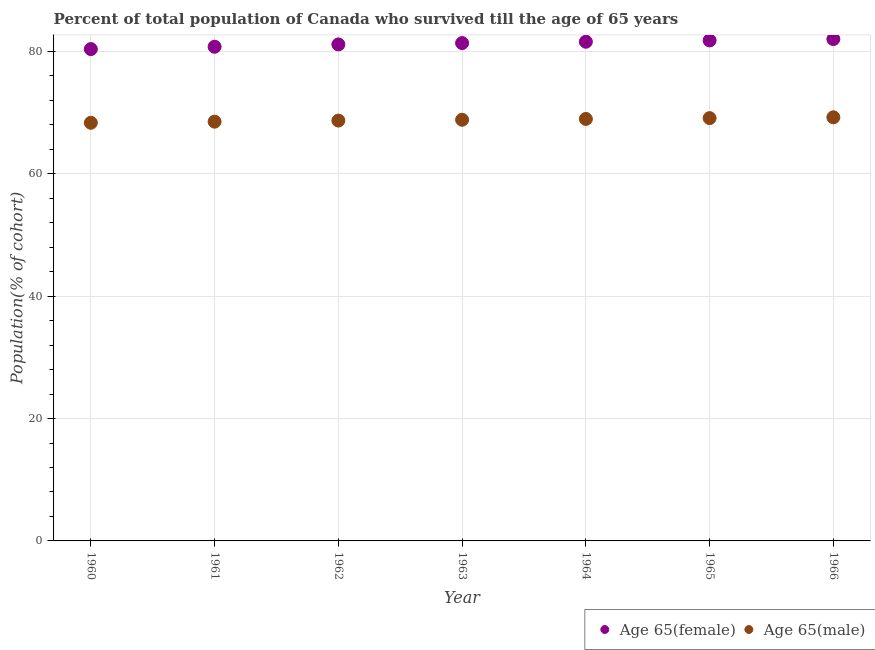What is the percentage of male population who survived till age of 65 in 1964?
Your answer should be compact. 68.96. Across all years, what is the maximum percentage of male population who survived till age of 65?
Ensure brevity in your answer.  69.23. Across all years, what is the minimum percentage of female population who survived till age of 65?
Ensure brevity in your answer.  80.38. In which year was the percentage of female population who survived till age of 65 maximum?
Keep it short and to the point. 1966. What is the total percentage of female population who survived till age of 65 in the graph?
Your answer should be very brief. 569.01. What is the difference between the percentage of female population who survived till age of 65 in 1960 and that in 1965?
Your answer should be very brief. -1.42. What is the difference between the percentage of male population who survived till age of 65 in 1963 and the percentage of female population who survived till age of 65 in 1962?
Make the answer very short. -12.31. What is the average percentage of male population who survived till age of 65 per year?
Provide a succinct answer. 68.81. In the year 1962, what is the difference between the percentage of male population who survived till age of 65 and percentage of female population who survived till age of 65?
Provide a short and direct response. -12.44. In how many years, is the percentage of male population who survived till age of 65 greater than 60 %?
Provide a succinct answer. 7. What is the ratio of the percentage of male population who survived till age of 65 in 1961 to that in 1965?
Offer a very short reply. 0.99. Is the percentage of male population who survived till age of 65 in 1963 less than that in 1964?
Keep it short and to the point. Yes. Is the difference between the percentage of male population who survived till age of 65 in 1961 and 1962 greater than the difference between the percentage of female population who survived till age of 65 in 1961 and 1962?
Provide a succinct answer. Yes. What is the difference between the highest and the second highest percentage of male population who survived till age of 65?
Ensure brevity in your answer.  0.13. What is the difference between the highest and the lowest percentage of female population who survived till age of 65?
Keep it short and to the point. 1.64. Is the sum of the percentage of female population who survived till age of 65 in 1961 and 1963 greater than the maximum percentage of male population who survived till age of 65 across all years?
Keep it short and to the point. Yes. Does the percentage of male population who survived till age of 65 monotonically increase over the years?
Offer a terse response. Yes. How many dotlines are there?
Offer a very short reply. 2. How many years are there in the graph?
Keep it short and to the point. 7. What is the difference between two consecutive major ticks on the Y-axis?
Give a very brief answer. 20. Are the values on the major ticks of Y-axis written in scientific E-notation?
Provide a short and direct response. No. Does the graph contain any zero values?
Ensure brevity in your answer.  No. Where does the legend appear in the graph?
Your response must be concise. Bottom right. How many legend labels are there?
Your answer should be compact. 2. How are the legend labels stacked?
Provide a short and direct response. Horizontal. What is the title of the graph?
Your answer should be compact. Percent of total population of Canada who survived till the age of 65 years. Does "Working only" appear as one of the legend labels in the graph?
Offer a terse response. No. What is the label or title of the Y-axis?
Your answer should be compact. Population(% of cohort). What is the Population(% of cohort) of Age 65(female) in 1960?
Your response must be concise. 80.38. What is the Population(% of cohort) in Age 65(male) in 1960?
Offer a terse response. 68.33. What is the Population(% of cohort) in Age 65(female) in 1961?
Offer a very short reply. 80.76. What is the Population(% of cohort) in Age 65(male) in 1961?
Provide a succinct answer. 68.51. What is the Population(% of cohort) in Age 65(female) in 1962?
Make the answer very short. 81.14. What is the Population(% of cohort) in Age 65(male) in 1962?
Give a very brief answer. 68.69. What is the Population(% of cohort) of Age 65(female) in 1963?
Provide a short and direct response. 81.36. What is the Population(% of cohort) in Age 65(male) in 1963?
Offer a very short reply. 68.83. What is the Population(% of cohort) in Age 65(female) in 1964?
Offer a very short reply. 81.57. What is the Population(% of cohort) in Age 65(male) in 1964?
Give a very brief answer. 68.96. What is the Population(% of cohort) in Age 65(female) in 1965?
Offer a terse response. 81.79. What is the Population(% of cohort) of Age 65(male) in 1965?
Give a very brief answer. 69.09. What is the Population(% of cohort) in Age 65(female) in 1966?
Your response must be concise. 82.01. What is the Population(% of cohort) of Age 65(male) in 1966?
Your answer should be very brief. 69.23. Across all years, what is the maximum Population(% of cohort) in Age 65(female)?
Give a very brief answer. 82.01. Across all years, what is the maximum Population(% of cohort) of Age 65(male)?
Your answer should be compact. 69.23. Across all years, what is the minimum Population(% of cohort) in Age 65(female)?
Your answer should be very brief. 80.38. Across all years, what is the minimum Population(% of cohort) of Age 65(male)?
Your answer should be compact. 68.33. What is the total Population(% of cohort) in Age 65(female) in the graph?
Make the answer very short. 569.01. What is the total Population(% of cohort) in Age 65(male) in the graph?
Ensure brevity in your answer.  481.65. What is the difference between the Population(% of cohort) in Age 65(female) in 1960 and that in 1961?
Make the answer very short. -0.38. What is the difference between the Population(% of cohort) of Age 65(male) in 1960 and that in 1961?
Your response must be concise. -0.18. What is the difference between the Population(% of cohort) in Age 65(female) in 1960 and that in 1962?
Your answer should be compact. -0.76. What is the difference between the Population(% of cohort) in Age 65(male) in 1960 and that in 1962?
Your answer should be very brief. -0.36. What is the difference between the Population(% of cohort) of Age 65(female) in 1960 and that in 1963?
Your answer should be compact. -0.98. What is the difference between the Population(% of cohort) in Age 65(male) in 1960 and that in 1963?
Keep it short and to the point. -0.49. What is the difference between the Population(% of cohort) of Age 65(female) in 1960 and that in 1964?
Your response must be concise. -1.2. What is the difference between the Population(% of cohort) in Age 65(male) in 1960 and that in 1964?
Keep it short and to the point. -0.63. What is the difference between the Population(% of cohort) in Age 65(female) in 1960 and that in 1965?
Ensure brevity in your answer.  -1.42. What is the difference between the Population(% of cohort) in Age 65(male) in 1960 and that in 1965?
Your answer should be compact. -0.76. What is the difference between the Population(% of cohort) in Age 65(female) in 1960 and that in 1966?
Offer a very short reply. -1.64. What is the difference between the Population(% of cohort) of Age 65(male) in 1960 and that in 1966?
Make the answer very short. -0.9. What is the difference between the Population(% of cohort) in Age 65(female) in 1961 and that in 1962?
Make the answer very short. -0.38. What is the difference between the Population(% of cohort) in Age 65(male) in 1961 and that in 1962?
Provide a short and direct response. -0.18. What is the difference between the Population(% of cohort) of Age 65(female) in 1961 and that in 1963?
Your answer should be compact. -0.6. What is the difference between the Population(% of cohort) in Age 65(male) in 1961 and that in 1963?
Provide a succinct answer. -0.31. What is the difference between the Population(% of cohort) in Age 65(female) in 1961 and that in 1964?
Your answer should be compact. -0.82. What is the difference between the Population(% of cohort) in Age 65(male) in 1961 and that in 1964?
Provide a succinct answer. -0.45. What is the difference between the Population(% of cohort) in Age 65(female) in 1961 and that in 1965?
Offer a terse response. -1.04. What is the difference between the Population(% of cohort) of Age 65(male) in 1961 and that in 1965?
Offer a terse response. -0.58. What is the difference between the Population(% of cohort) in Age 65(female) in 1961 and that in 1966?
Keep it short and to the point. -1.26. What is the difference between the Population(% of cohort) in Age 65(male) in 1961 and that in 1966?
Your answer should be very brief. -0.72. What is the difference between the Population(% of cohort) in Age 65(female) in 1962 and that in 1963?
Provide a short and direct response. -0.22. What is the difference between the Population(% of cohort) in Age 65(male) in 1962 and that in 1963?
Your answer should be very brief. -0.13. What is the difference between the Population(% of cohort) in Age 65(female) in 1962 and that in 1964?
Offer a very short reply. -0.44. What is the difference between the Population(% of cohort) in Age 65(male) in 1962 and that in 1964?
Provide a short and direct response. -0.27. What is the difference between the Population(% of cohort) in Age 65(female) in 1962 and that in 1965?
Give a very brief answer. -0.66. What is the difference between the Population(% of cohort) of Age 65(male) in 1962 and that in 1965?
Your response must be concise. -0.4. What is the difference between the Population(% of cohort) in Age 65(female) in 1962 and that in 1966?
Your answer should be compact. -0.88. What is the difference between the Population(% of cohort) in Age 65(male) in 1962 and that in 1966?
Your response must be concise. -0.54. What is the difference between the Population(% of cohort) of Age 65(female) in 1963 and that in 1964?
Your answer should be compact. -0.22. What is the difference between the Population(% of cohort) in Age 65(male) in 1963 and that in 1964?
Give a very brief answer. -0.13. What is the difference between the Population(% of cohort) of Age 65(female) in 1963 and that in 1965?
Offer a terse response. -0.44. What is the difference between the Population(% of cohort) in Age 65(male) in 1963 and that in 1965?
Make the answer very short. -0.27. What is the difference between the Population(% of cohort) of Age 65(female) in 1963 and that in 1966?
Offer a terse response. -0.66. What is the difference between the Population(% of cohort) in Age 65(male) in 1963 and that in 1966?
Your answer should be very brief. -0.4. What is the difference between the Population(% of cohort) in Age 65(female) in 1964 and that in 1965?
Your answer should be very brief. -0.22. What is the difference between the Population(% of cohort) of Age 65(male) in 1964 and that in 1965?
Keep it short and to the point. -0.13. What is the difference between the Population(% of cohort) of Age 65(female) in 1964 and that in 1966?
Provide a short and direct response. -0.44. What is the difference between the Population(% of cohort) of Age 65(male) in 1964 and that in 1966?
Your response must be concise. -0.27. What is the difference between the Population(% of cohort) in Age 65(female) in 1965 and that in 1966?
Offer a terse response. -0.22. What is the difference between the Population(% of cohort) of Age 65(male) in 1965 and that in 1966?
Your response must be concise. -0.13. What is the difference between the Population(% of cohort) in Age 65(female) in 1960 and the Population(% of cohort) in Age 65(male) in 1961?
Make the answer very short. 11.86. What is the difference between the Population(% of cohort) in Age 65(female) in 1960 and the Population(% of cohort) in Age 65(male) in 1962?
Provide a succinct answer. 11.68. What is the difference between the Population(% of cohort) of Age 65(female) in 1960 and the Population(% of cohort) of Age 65(male) in 1963?
Offer a very short reply. 11.55. What is the difference between the Population(% of cohort) of Age 65(female) in 1960 and the Population(% of cohort) of Age 65(male) in 1964?
Your answer should be compact. 11.41. What is the difference between the Population(% of cohort) of Age 65(female) in 1960 and the Population(% of cohort) of Age 65(male) in 1965?
Give a very brief answer. 11.28. What is the difference between the Population(% of cohort) of Age 65(female) in 1960 and the Population(% of cohort) of Age 65(male) in 1966?
Make the answer very short. 11.15. What is the difference between the Population(% of cohort) in Age 65(female) in 1961 and the Population(% of cohort) in Age 65(male) in 1962?
Give a very brief answer. 12.06. What is the difference between the Population(% of cohort) of Age 65(female) in 1961 and the Population(% of cohort) of Age 65(male) in 1963?
Ensure brevity in your answer.  11.93. What is the difference between the Population(% of cohort) of Age 65(female) in 1961 and the Population(% of cohort) of Age 65(male) in 1964?
Give a very brief answer. 11.79. What is the difference between the Population(% of cohort) in Age 65(female) in 1961 and the Population(% of cohort) in Age 65(male) in 1965?
Keep it short and to the point. 11.66. What is the difference between the Population(% of cohort) of Age 65(female) in 1961 and the Population(% of cohort) of Age 65(male) in 1966?
Your response must be concise. 11.53. What is the difference between the Population(% of cohort) in Age 65(female) in 1962 and the Population(% of cohort) in Age 65(male) in 1963?
Provide a short and direct response. 12.31. What is the difference between the Population(% of cohort) of Age 65(female) in 1962 and the Population(% of cohort) of Age 65(male) in 1964?
Your answer should be compact. 12.17. What is the difference between the Population(% of cohort) of Age 65(female) in 1962 and the Population(% of cohort) of Age 65(male) in 1965?
Your response must be concise. 12.04. What is the difference between the Population(% of cohort) in Age 65(female) in 1962 and the Population(% of cohort) in Age 65(male) in 1966?
Provide a succinct answer. 11.91. What is the difference between the Population(% of cohort) of Age 65(female) in 1963 and the Population(% of cohort) of Age 65(male) in 1964?
Provide a short and direct response. 12.39. What is the difference between the Population(% of cohort) in Age 65(female) in 1963 and the Population(% of cohort) in Age 65(male) in 1965?
Provide a short and direct response. 12.26. What is the difference between the Population(% of cohort) in Age 65(female) in 1963 and the Population(% of cohort) in Age 65(male) in 1966?
Offer a terse response. 12.13. What is the difference between the Population(% of cohort) of Age 65(female) in 1964 and the Population(% of cohort) of Age 65(male) in 1965?
Provide a short and direct response. 12.48. What is the difference between the Population(% of cohort) in Age 65(female) in 1964 and the Population(% of cohort) in Age 65(male) in 1966?
Provide a succinct answer. 12.35. What is the difference between the Population(% of cohort) of Age 65(female) in 1965 and the Population(% of cohort) of Age 65(male) in 1966?
Keep it short and to the point. 12.57. What is the average Population(% of cohort) of Age 65(female) per year?
Provide a short and direct response. 81.29. What is the average Population(% of cohort) in Age 65(male) per year?
Your answer should be compact. 68.81. In the year 1960, what is the difference between the Population(% of cohort) in Age 65(female) and Population(% of cohort) in Age 65(male)?
Your answer should be very brief. 12.04. In the year 1961, what is the difference between the Population(% of cohort) of Age 65(female) and Population(% of cohort) of Age 65(male)?
Keep it short and to the point. 12.24. In the year 1962, what is the difference between the Population(% of cohort) in Age 65(female) and Population(% of cohort) in Age 65(male)?
Make the answer very short. 12.44. In the year 1963, what is the difference between the Population(% of cohort) in Age 65(female) and Population(% of cohort) in Age 65(male)?
Your answer should be compact. 12.53. In the year 1964, what is the difference between the Population(% of cohort) in Age 65(female) and Population(% of cohort) in Age 65(male)?
Your response must be concise. 12.61. In the year 1965, what is the difference between the Population(% of cohort) of Age 65(female) and Population(% of cohort) of Age 65(male)?
Offer a very short reply. 12.7. In the year 1966, what is the difference between the Population(% of cohort) in Age 65(female) and Population(% of cohort) in Age 65(male)?
Provide a succinct answer. 12.78. What is the ratio of the Population(% of cohort) of Age 65(female) in 1960 to that in 1961?
Keep it short and to the point. 1. What is the ratio of the Population(% of cohort) in Age 65(female) in 1960 to that in 1962?
Keep it short and to the point. 0.99. What is the ratio of the Population(% of cohort) of Age 65(male) in 1960 to that in 1962?
Your answer should be compact. 0.99. What is the ratio of the Population(% of cohort) of Age 65(female) in 1960 to that in 1963?
Make the answer very short. 0.99. What is the ratio of the Population(% of cohort) of Age 65(male) in 1960 to that in 1963?
Your answer should be compact. 0.99. What is the ratio of the Population(% of cohort) of Age 65(female) in 1960 to that in 1964?
Ensure brevity in your answer.  0.99. What is the ratio of the Population(% of cohort) of Age 65(male) in 1960 to that in 1964?
Your answer should be compact. 0.99. What is the ratio of the Population(% of cohort) in Age 65(female) in 1960 to that in 1965?
Ensure brevity in your answer.  0.98. What is the ratio of the Population(% of cohort) of Age 65(male) in 1960 to that in 1965?
Provide a succinct answer. 0.99. What is the ratio of the Population(% of cohort) in Age 65(female) in 1960 to that in 1966?
Your answer should be compact. 0.98. What is the ratio of the Population(% of cohort) of Age 65(male) in 1960 to that in 1966?
Provide a succinct answer. 0.99. What is the ratio of the Population(% of cohort) in Age 65(male) in 1961 to that in 1962?
Give a very brief answer. 1. What is the ratio of the Population(% of cohort) of Age 65(male) in 1961 to that in 1964?
Offer a terse response. 0.99. What is the ratio of the Population(% of cohort) in Age 65(female) in 1961 to that in 1965?
Make the answer very short. 0.99. What is the ratio of the Population(% of cohort) of Age 65(female) in 1961 to that in 1966?
Your answer should be very brief. 0.98. What is the ratio of the Population(% of cohort) of Age 65(male) in 1961 to that in 1966?
Provide a succinct answer. 0.99. What is the ratio of the Population(% of cohort) of Age 65(male) in 1962 to that in 1963?
Give a very brief answer. 1. What is the ratio of the Population(% of cohort) of Age 65(female) in 1962 to that in 1964?
Provide a succinct answer. 0.99. What is the ratio of the Population(% of cohort) of Age 65(male) in 1962 to that in 1965?
Offer a terse response. 0.99. What is the ratio of the Population(% of cohort) of Age 65(female) in 1962 to that in 1966?
Offer a very short reply. 0.99. What is the ratio of the Population(% of cohort) in Age 65(female) in 1963 to that in 1964?
Provide a succinct answer. 1. What is the ratio of the Population(% of cohort) in Age 65(male) in 1963 to that in 1964?
Make the answer very short. 1. What is the ratio of the Population(% of cohort) in Age 65(male) in 1963 to that in 1966?
Provide a succinct answer. 0.99. What is the ratio of the Population(% of cohort) of Age 65(male) in 1964 to that in 1966?
Make the answer very short. 1. What is the ratio of the Population(% of cohort) in Age 65(female) in 1965 to that in 1966?
Give a very brief answer. 1. What is the ratio of the Population(% of cohort) of Age 65(male) in 1965 to that in 1966?
Your answer should be compact. 1. What is the difference between the highest and the second highest Population(% of cohort) in Age 65(female)?
Offer a very short reply. 0.22. What is the difference between the highest and the second highest Population(% of cohort) in Age 65(male)?
Keep it short and to the point. 0.13. What is the difference between the highest and the lowest Population(% of cohort) in Age 65(female)?
Offer a terse response. 1.64. What is the difference between the highest and the lowest Population(% of cohort) of Age 65(male)?
Provide a short and direct response. 0.9. 